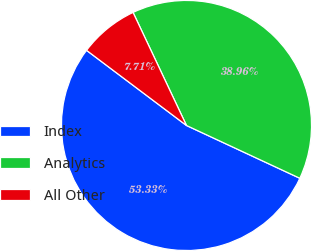Convert chart. <chart><loc_0><loc_0><loc_500><loc_500><pie_chart><fcel>Index<fcel>Analytics<fcel>All Other<nl><fcel>53.32%<fcel>38.96%<fcel>7.71%<nl></chart> 